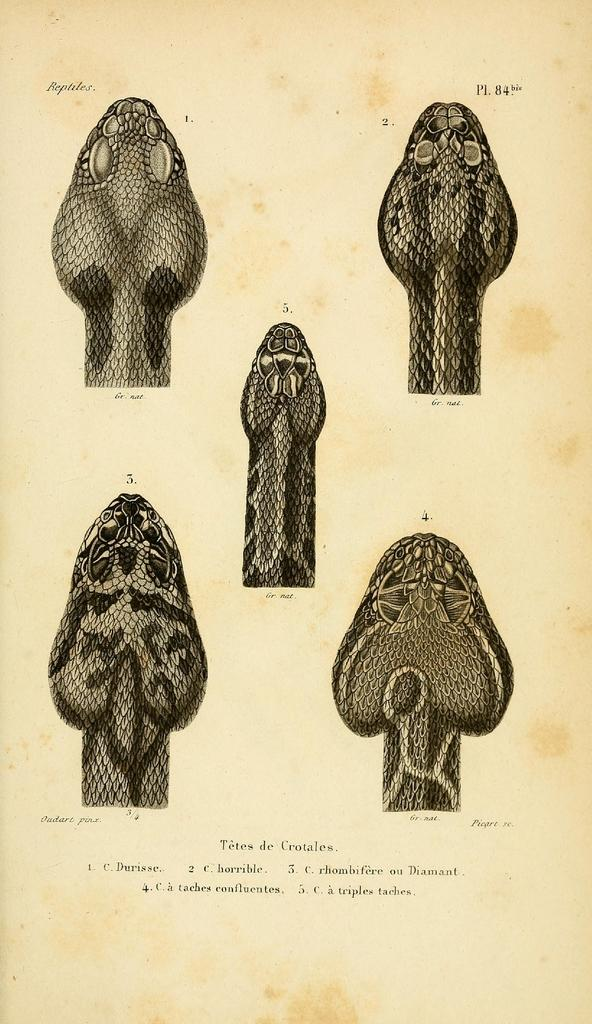What type of animals are present in the image? There are snakes in the image. What part of the snakes can be seen? The snakes' heads are visible in the image. What else is present in the image besides the snakes? There is a paper in the image. What information is on the paper? The paper contains words and numbers. Can you tell me how many grapes are on the snakes in the image? There are no grapes present in the image; it features snakes and a paper with words and numbers. Is there a credit card visible in the image? There is no credit card present in the image. 